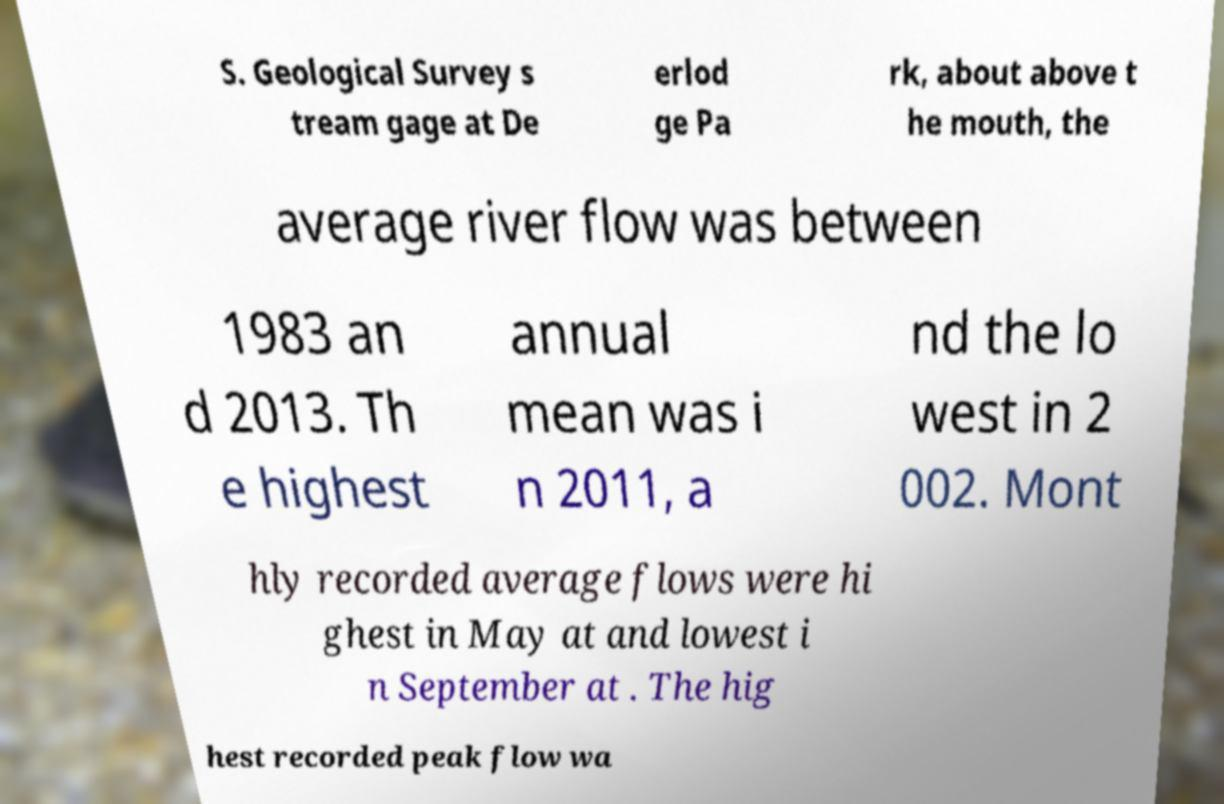Please read and relay the text visible in this image. What does it say? S. Geological Survey s tream gage at De erlod ge Pa rk, about above t he mouth, the average river flow was between 1983 an d 2013. Th e highest annual mean was i n 2011, a nd the lo west in 2 002. Mont hly recorded average flows were hi ghest in May at and lowest i n September at . The hig hest recorded peak flow wa 